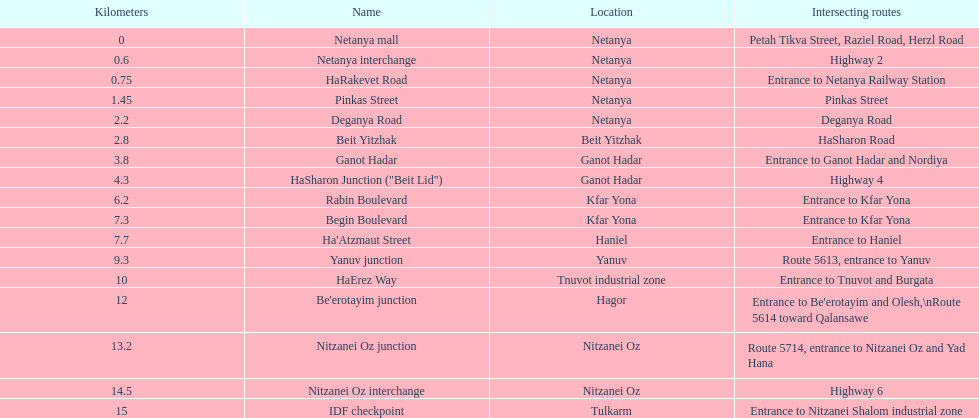Which site is subsequent to kfar yona? Haniel. 